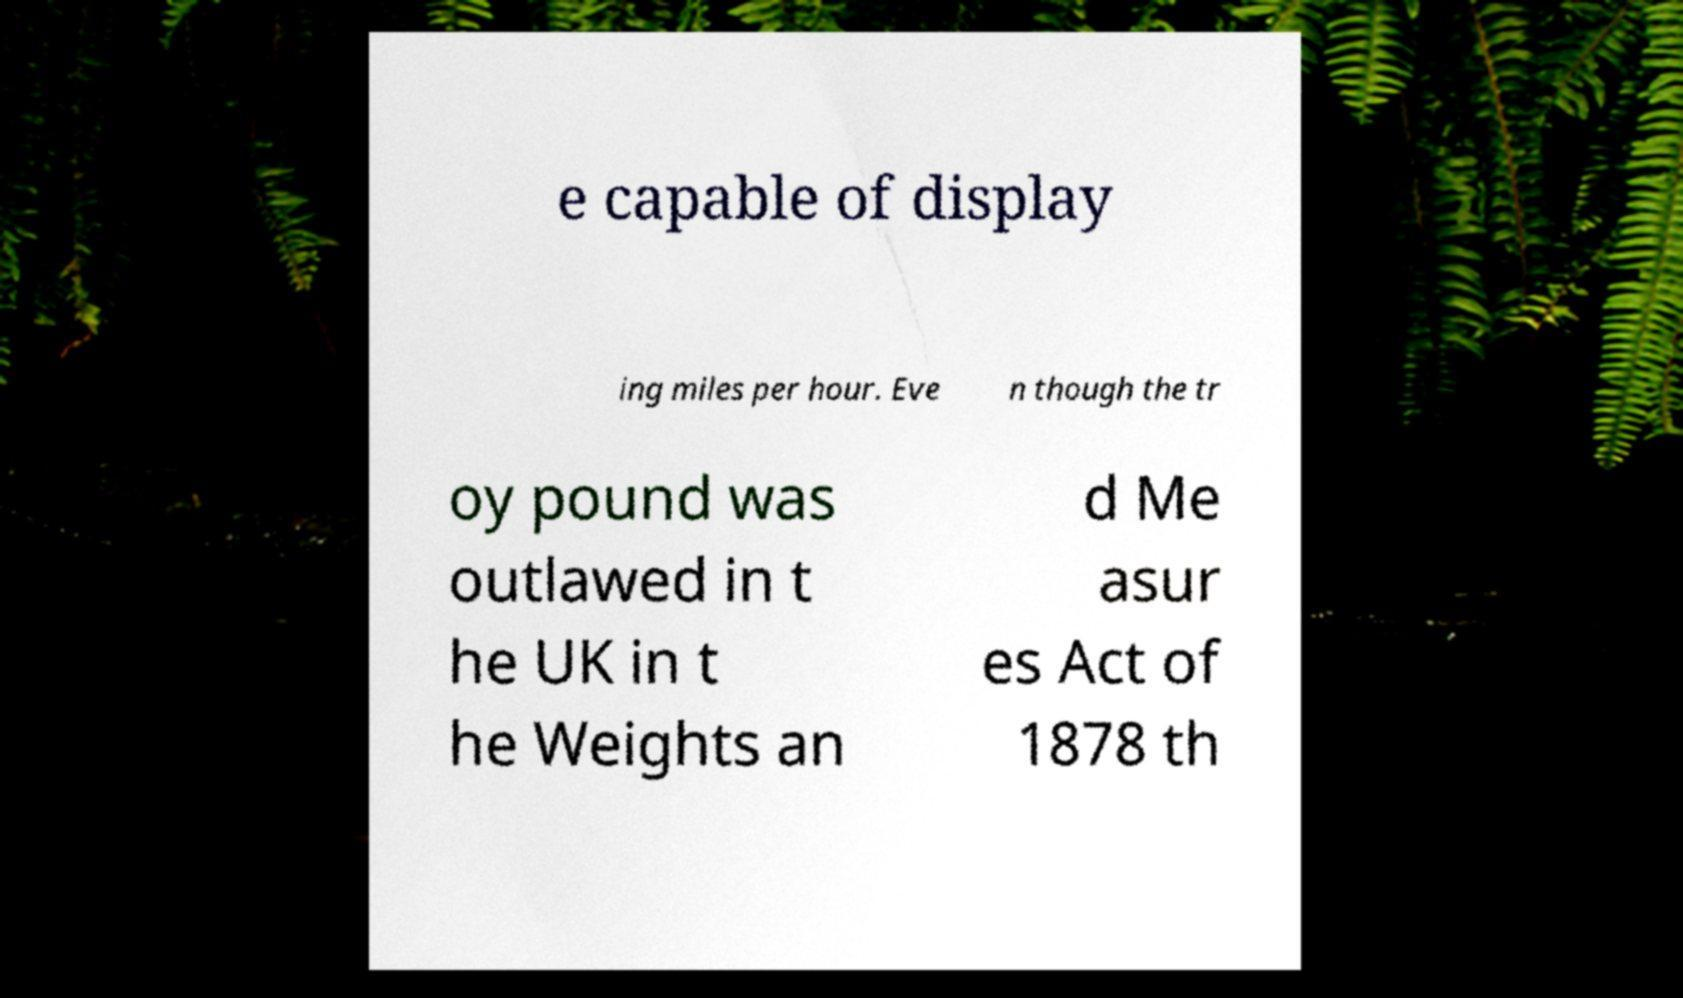Can you read and provide the text displayed in the image?This photo seems to have some interesting text. Can you extract and type it out for me? e capable of display ing miles per hour. Eve n though the tr oy pound was outlawed in t he UK in t he Weights an d Me asur es Act of 1878 th 